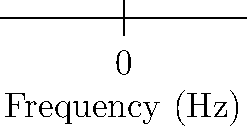Based on the graph comparing DMM (Direct Metal Mastering) and Direct Cut vinyl pressing techniques, which method appears to maintain better high-frequency response above 5000 Hz? To answer this question, we need to analyze the graph and compare the two curves:

1. The blue curve represents the DMM (Direct Metal Mastering) technique.
2. The red curve represents the Direct Cut technique.
3. We need to focus on the frequency range above 5000 Hz.
4. At 5000 Hz, both techniques show similar amplitude (around 0.8).
5. As we move towards higher frequencies (10000 Hz and 20000 Hz):
   - The DMM curve (blue) shows a steeper decline in amplitude.
   - The Direct Cut curve (red) maintains a higher amplitude.
6. At 20000 Hz, the Direct Cut technique shows an amplitude of about 0.8, while DMM is around 0.6.
7. This indicates that the Direct Cut technique preserves more high-frequency information.

Therefore, based on this graph, the Direct Cut vinyl pressing technique appears to maintain better high-frequency response above 5000 Hz compared to the DMM technique.
Answer: Direct Cut 